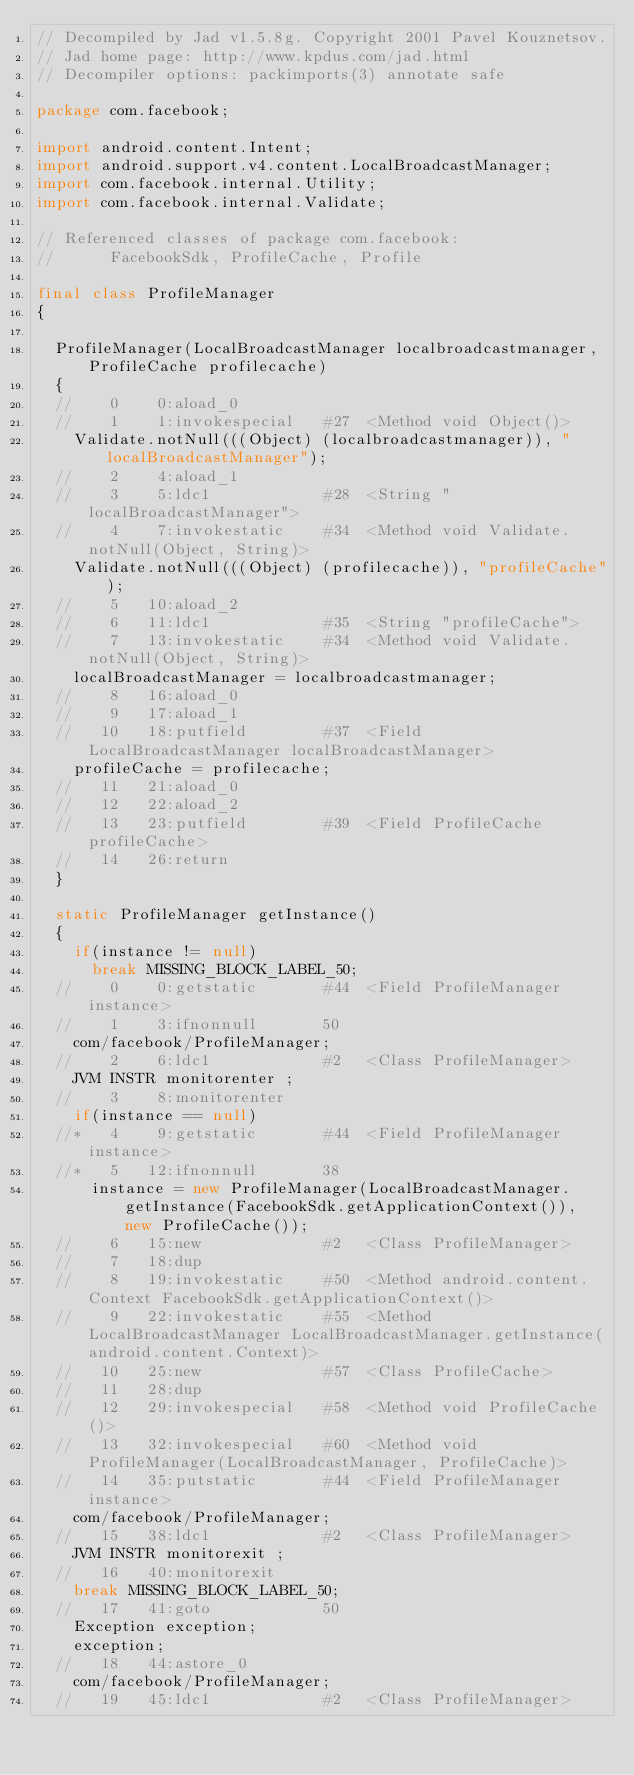<code> <loc_0><loc_0><loc_500><loc_500><_Java_>// Decompiled by Jad v1.5.8g. Copyright 2001 Pavel Kouznetsov.
// Jad home page: http://www.kpdus.com/jad.html
// Decompiler options: packimports(3) annotate safe 

package com.facebook;

import android.content.Intent;
import android.support.v4.content.LocalBroadcastManager;
import com.facebook.internal.Utility;
import com.facebook.internal.Validate;

// Referenced classes of package com.facebook:
//			FacebookSdk, ProfileCache, Profile

final class ProfileManager
{

	ProfileManager(LocalBroadcastManager localbroadcastmanager, ProfileCache profilecache)
	{
	//    0    0:aload_0         
	//    1    1:invokespecial   #27  <Method void Object()>
		Validate.notNull(((Object) (localbroadcastmanager)), "localBroadcastManager");
	//    2    4:aload_1         
	//    3    5:ldc1            #28  <String "localBroadcastManager">
	//    4    7:invokestatic    #34  <Method void Validate.notNull(Object, String)>
		Validate.notNull(((Object) (profilecache)), "profileCache");
	//    5   10:aload_2         
	//    6   11:ldc1            #35  <String "profileCache">
	//    7   13:invokestatic    #34  <Method void Validate.notNull(Object, String)>
		localBroadcastManager = localbroadcastmanager;
	//    8   16:aload_0         
	//    9   17:aload_1         
	//   10   18:putfield        #37  <Field LocalBroadcastManager localBroadcastManager>
		profileCache = profilecache;
	//   11   21:aload_0         
	//   12   22:aload_2         
	//   13   23:putfield        #39  <Field ProfileCache profileCache>
	//   14   26:return          
	}

	static ProfileManager getInstance()
	{
		if(instance != null)
			break MISSING_BLOCK_LABEL_50;
	//    0    0:getstatic       #44  <Field ProfileManager instance>
	//    1    3:ifnonnull       50
		com/facebook/ProfileManager;
	//    2    6:ldc1            #2   <Class ProfileManager>
		JVM INSTR monitorenter ;
	//    3    8:monitorenter    
		if(instance == null)
	//*   4    9:getstatic       #44  <Field ProfileManager instance>
	//*   5   12:ifnonnull       38
			instance = new ProfileManager(LocalBroadcastManager.getInstance(FacebookSdk.getApplicationContext()), new ProfileCache());
	//    6   15:new             #2   <Class ProfileManager>
	//    7   18:dup             
	//    8   19:invokestatic    #50  <Method android.content.Context FacebookSdk.getApplicationContext()>
	//    9   22:invokestatic    #55  <Method LocalBroadcastManager LocalBroadcastManager.getInstance(android.content.Context)>
	//   10   25:new             #57  <Class ProfileCache>
	//   11   28:dup             
	//   12   29:invokespecial   #58  <Method void ProfileCache()>
	//   13   32:invokespecial   #60  <Method void ProfileManager(LocalBroadcastManager, ProfileCache)>
	//   14   35:putstatic       #44  <Field ProfileManager instance>
		com/facebook/ProfileManager;
	//   15   38:ldc1            #2   <Class ProfileManager>
		JVM INSTR monitorexit ;
	//   16   40:monitorexit     
		break MISSING_BLOCK_LABEL_50;
	//   17   41:goto            50
		Exception exception;
		exception;
	//   18   44:astore_0        
		com/facebook/ProfileManager;
	//   19   45:ldc1            #2   <Class ProfileManager></code> 